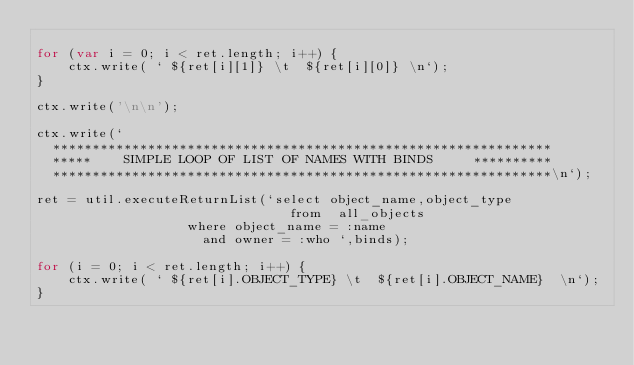<code> <loc_0><loc_0><loc_500><loc_500><_JavaScript_>
for (var i = 0; i < ret.length; i++) {
    ctx.write( ` ${ret[i][1]} \t  ${ret[i][0]} \n`);
}

ctx.write('\n\n');

ctx.write(`
  ***************************************************************
  *****    SIMPLE LOOP OF LIST OF NAMES WITH BINDS     **********
  ***************************************************************\n`);

ret = util.executeReturnList(`select object_name,object_type
                                from  all_objects
			       where object_name = :name
			         and owner = :who `,binds);

for (i = 0; i < ret.length; i++) {
    ctx.write( ` ${ret[i].OBJECT_TYPE} \t  ${ret[i].OBJECT_NAME}  \n`);
}
</code> 